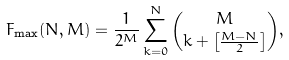<formula> <loc_0><loc_0><loc_500><loc_500>F _ { \max } ( N , M ) = \frac { 1 } { 2 ^ { M } } \sum _ { k = 0 } ^ { N } { M \choose k + \left [ \frac { M - N } { 2 } \right ] } ,</formula> 